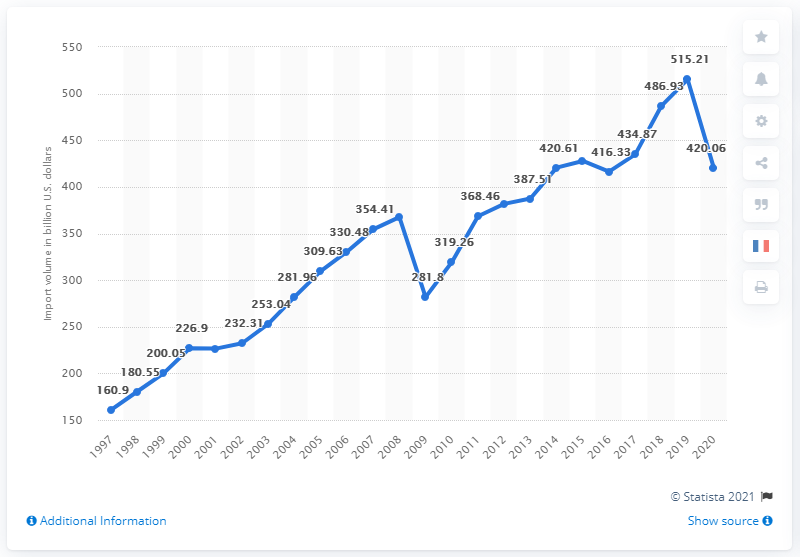Outline some significant characteristics in this image. In 2020, the value of imports from the EU was approximately $420.06 million in dollars. 